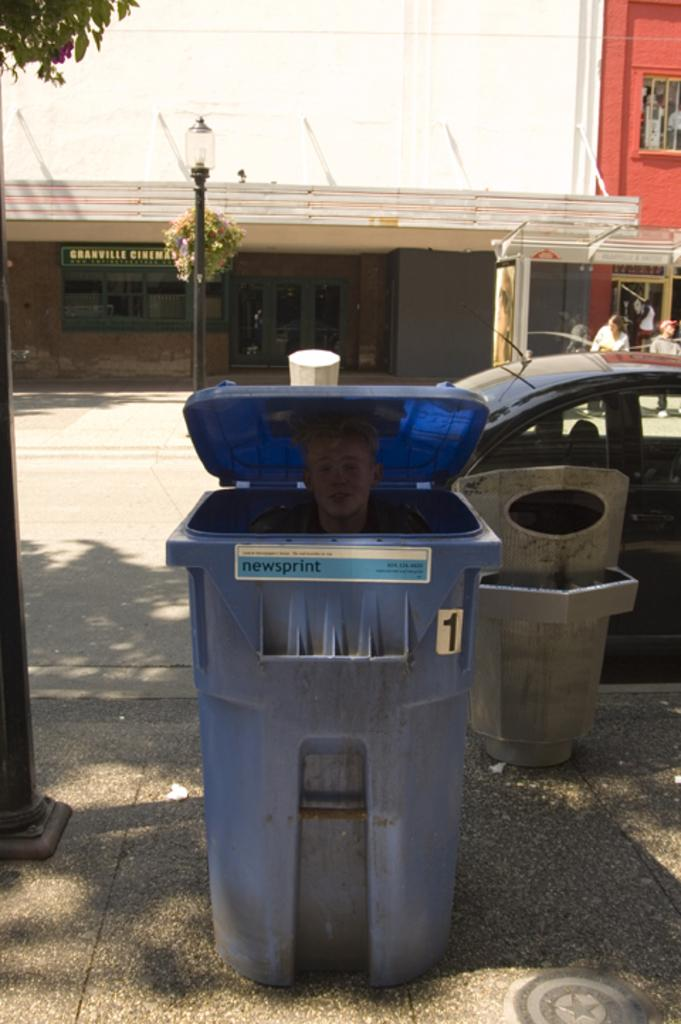<image>
Provide a brief description of the given image. A blue garbage can numbered 1 with a person inside 